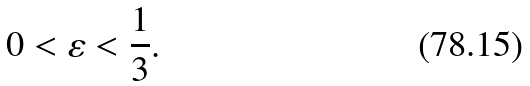<formula> <loc_0><loc_0><loc_500><loc_500>0 < \varepsilon < \frac { 1 } { 3 } .</formula> 